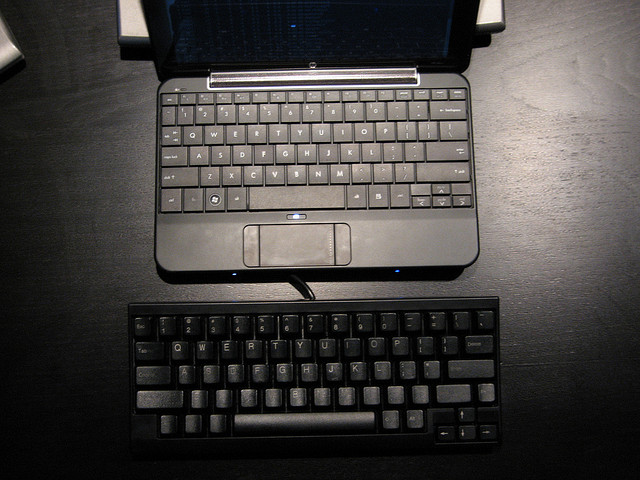Why are there two keyboards? In the image, we see a laptop with its own built-in keyboard and an additional external keyboard. This could be for a variety of reasons. Many users prefer the tactile feel of a full-sized external keyboard for ergonomic comfort, enhanced typing speed, or accuracy. It's also possible that the second keyboard is used for tasks that require a different language layout, or the user might switch between two systems, using a single external keyboard for convenience and efficiency. 